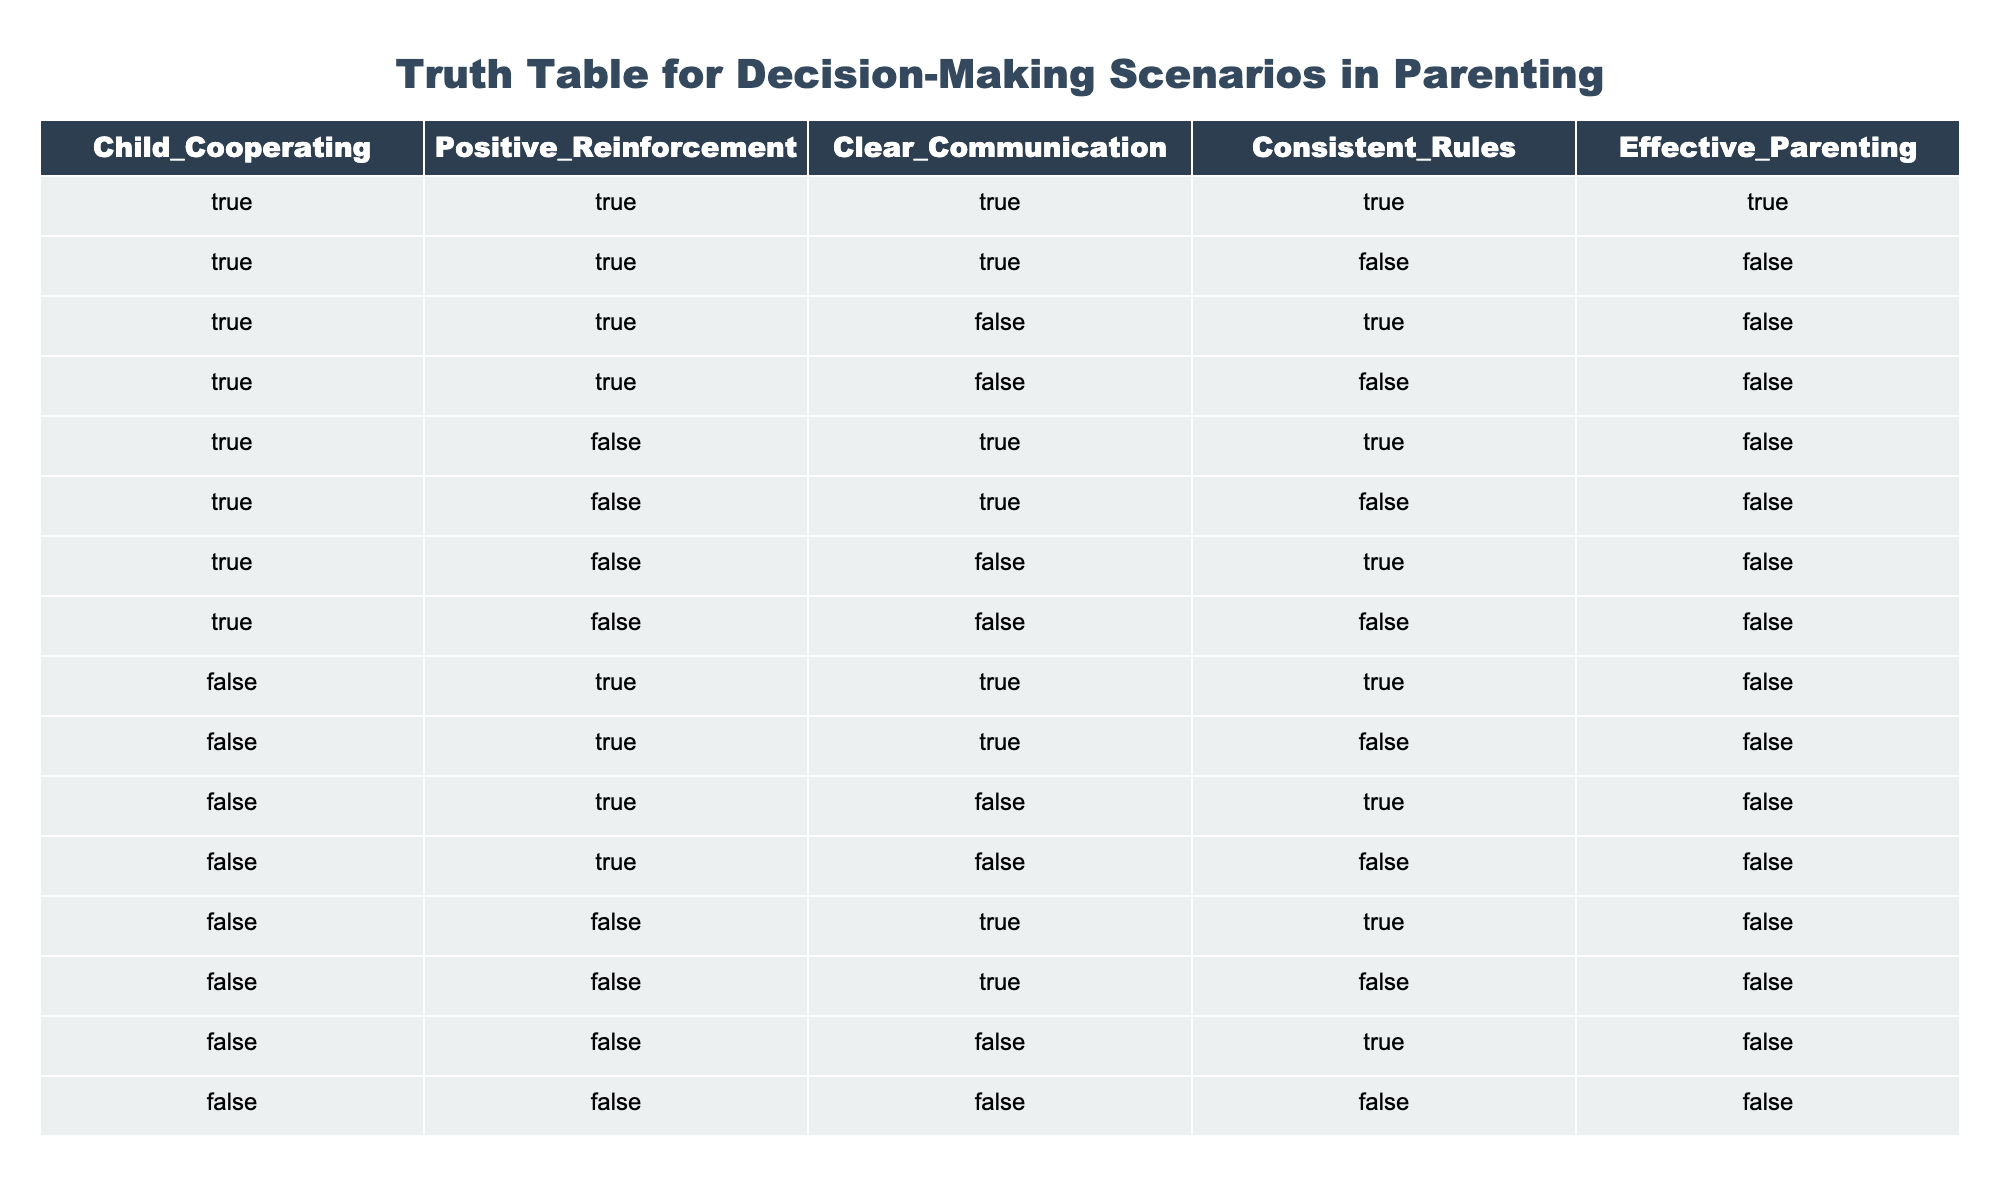What is the only combination of parenting strategies that leads to effective parenting? According to the table, the only row that results in "Effective Parenting" being true is when all four conditions—Child Cooperating, Positive Reinforcement, Clear Communication, and Consistent Rules—are true. This corresponds to the first row in the table.
Answer: TRUE How many scenarios lead to effective parenting when the child is not cooperating? By looking at the rows where "Child Cooperating" is FALSE, there are 8 rows in total. Since none of these lead to "Effective Parenting," the answer remains 0 effective scenarios.
Answer: 0 Is consistent rule enforcement necessary for effective parenting? The table indicates that even with other strategies in place, if Consistent Rules is FALSE, Effective Parenting cannot be TRUE. This confirms that consistent rule enforcement is necessary for effective parenting.
Answer: YES How many conditions need to be true to achieve effective parenting? In the first row, all four conditions must be true (Child Cooperating, Positive Reinforcement, Clear Communication, and Consistent Rules). There are no other combinations that achieve effective parenting.
Answer: 4 If Positive Reinforcement is FALSE, how many combinations can still lead to effective parenting? Reviewing the rows with Positive Reinforcement as FALSE shows that all combinations that include it lead to ineffective parenting. In fact, there are no scenarios that lead to effective outcomes when Positive Reinforcement is not applied.
Answer: 0 Is it possible to have effective parenting if Clear Communication is FALSE? Based on the table, when Clear Communication is FALSE, there are no scenarios that result in Effective Parenting, irrespective of other conditions. This confirms that Clear Communication is essential for effective parenting.
Answer: NO Which combination has the highest number of TRUE attributes, and does it lead to effective parenting? The rows with the highest number of TRUE attributes are where Child Cooperating, Positive Reinforcement, and Consistent Rules are TRUE while Clear Communication is FALSE. However, these scenarios are not effective since they yield FALSE for Effective Parenting.
Answer: FALSE What is the total count of scenarios where effective parenting occurs? Upon checking the table, there is only 1 scenario where Effective Parenting is TRUE. This is the first row where all strategies are aligned positively.
Answer: 1 